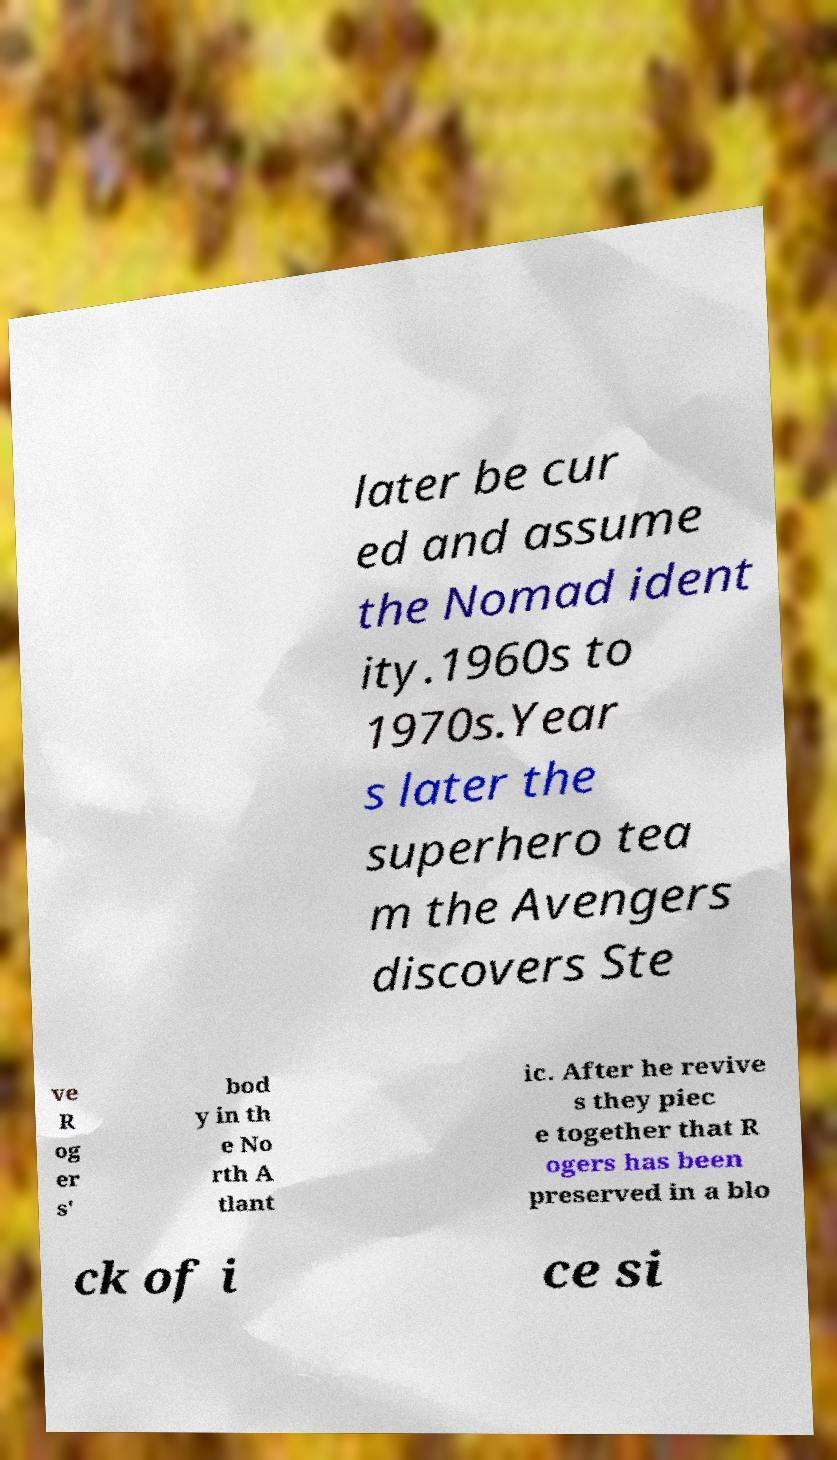Can you read and provide the text displayed in the image?This photo seems to have some interesting text. Can you extract and type it out for me? later be cur ed and assume the Nomad ident ity.1960s to 1970s.Year s later the superhero tea m the Avengers discovers Ste ve R og er s' bod y in th e No rth A tlant ic. After he revive s they piec e together that R ogers has been preserved in a blo ck of i ce si 